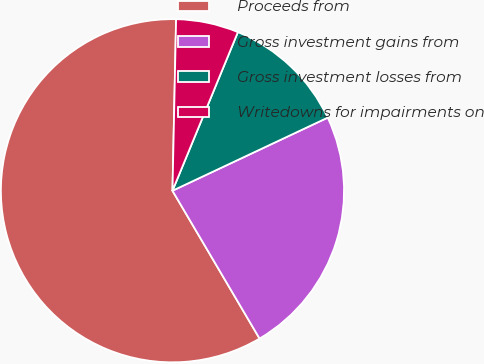Convert chart. <chart><loc_0><loc_0><loc_500><loc_500><pie_chart><fcel>Proceeds from<fcel>Gross investment gains from<fcel>Gross investment losses from<fcel>Writedowns for impairments on<nl><fcel>58.81%<fcel>23.53%<fcel>11.77%<fcel>5.89%<nl></chart> 